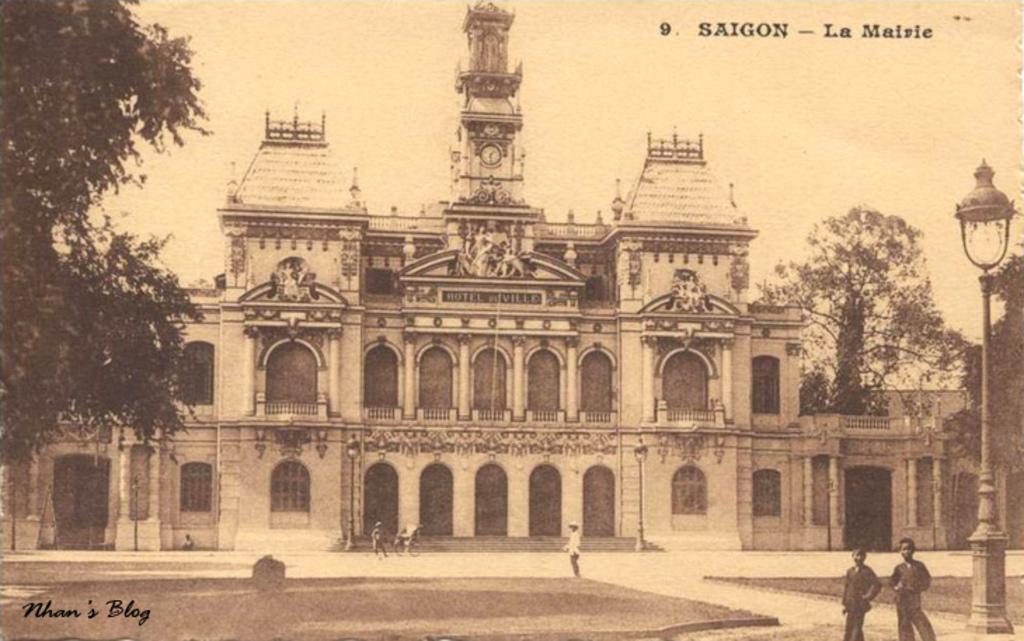Can you describe this image briefly? In this picture we can see a building. At the top of the building we can see a clock. On the right and left side of the picture we can see trees. On the right side of the picture we can see a light and pole. In the bottom left corner there is a watermark. 